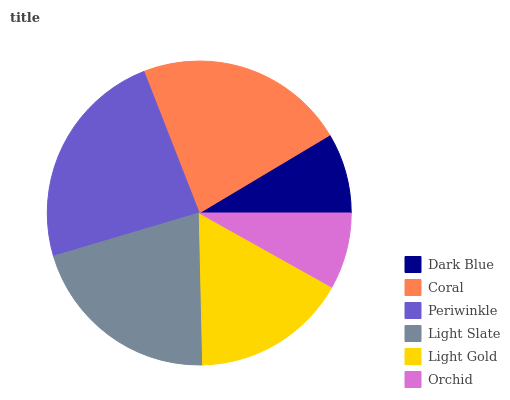Is Orchid the minimum?
Answer yes or no. Yes. Is Periwinkle the maximum?
Answer yes or no. Yes. Is Coral the minimum?
Answer yes or no. No. Is Coral the maximum?
Answer yes or no. No. Is Coral greater than Dark Blue?
Answer yes or no. Yes. Is Dark Blue less than Coral?
Answer yes or no. Yes. Is Dark Blue greater than Coral?
Answer yes or no. No. Is Coral less than Dark Blue?
Answer yes or no. No. Is Light Slate the high median?
Answer yes or no. Yes. Is Light Gold the low median?
Answer yes or no. Yes. Is Coral the high median?
Answer yes or no. No. Is Orchid the low median?
Answer yes or no. No. 